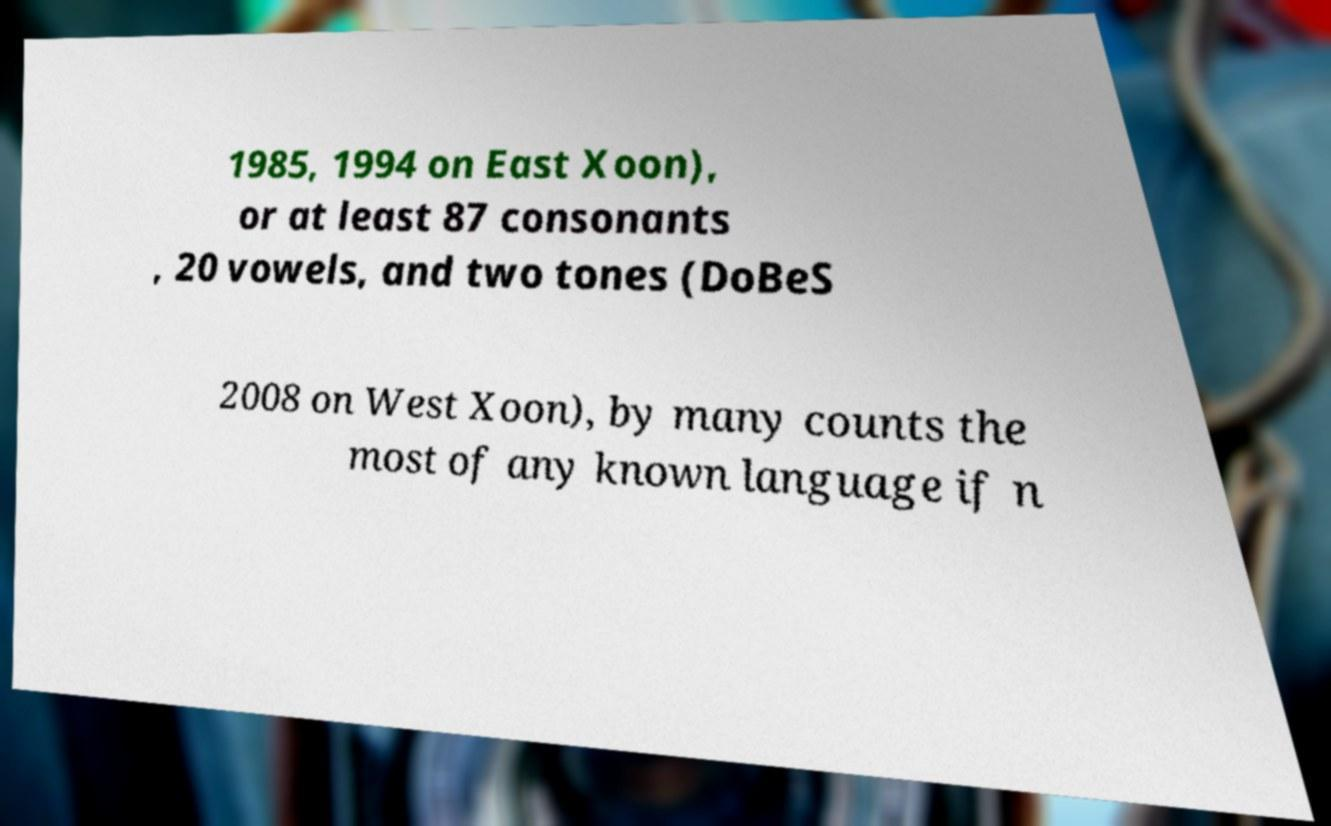Could you assist in decoding the text presented in this image and type it out clearly? 1985, 1994 on East Xoon), or at least 87 consonants , 20 vowels, and two tones (DoBeS 2008 on West Xoon), by many counts the most of any known language if n 